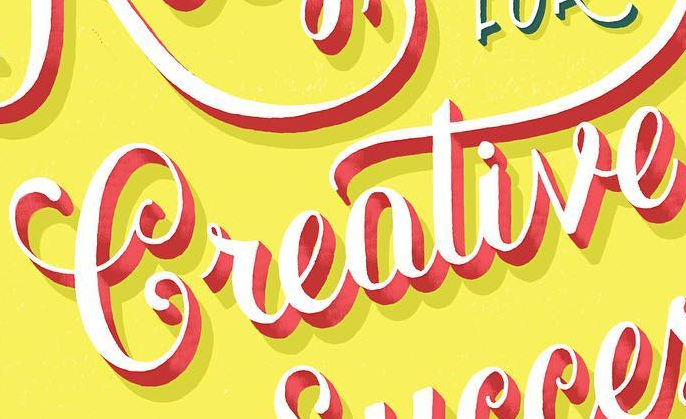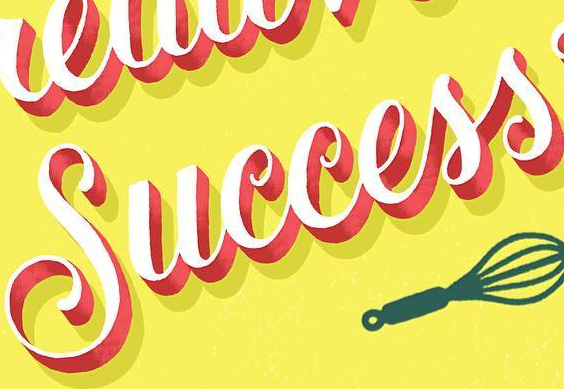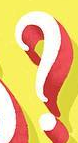What text is displayed in these images sequentially, separated by a semicolon? Creative; Success; ? 